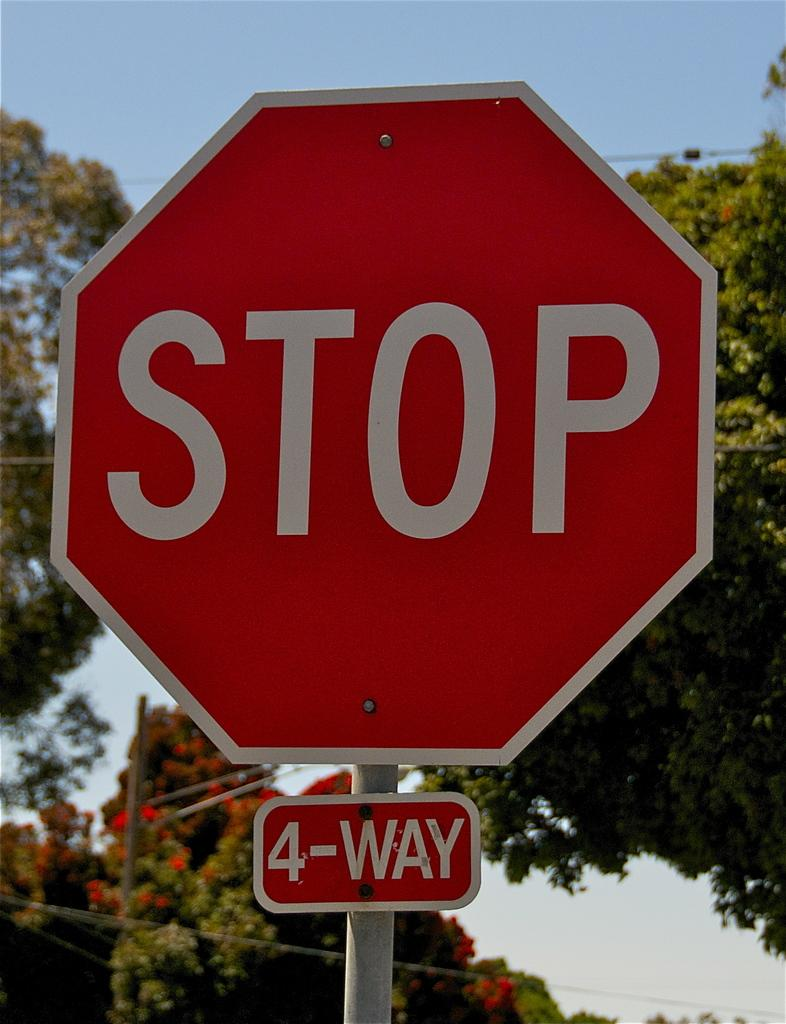<image>
Present a compact description of the photo's key features. a stop sign with the words 4 way at the bottom of it 